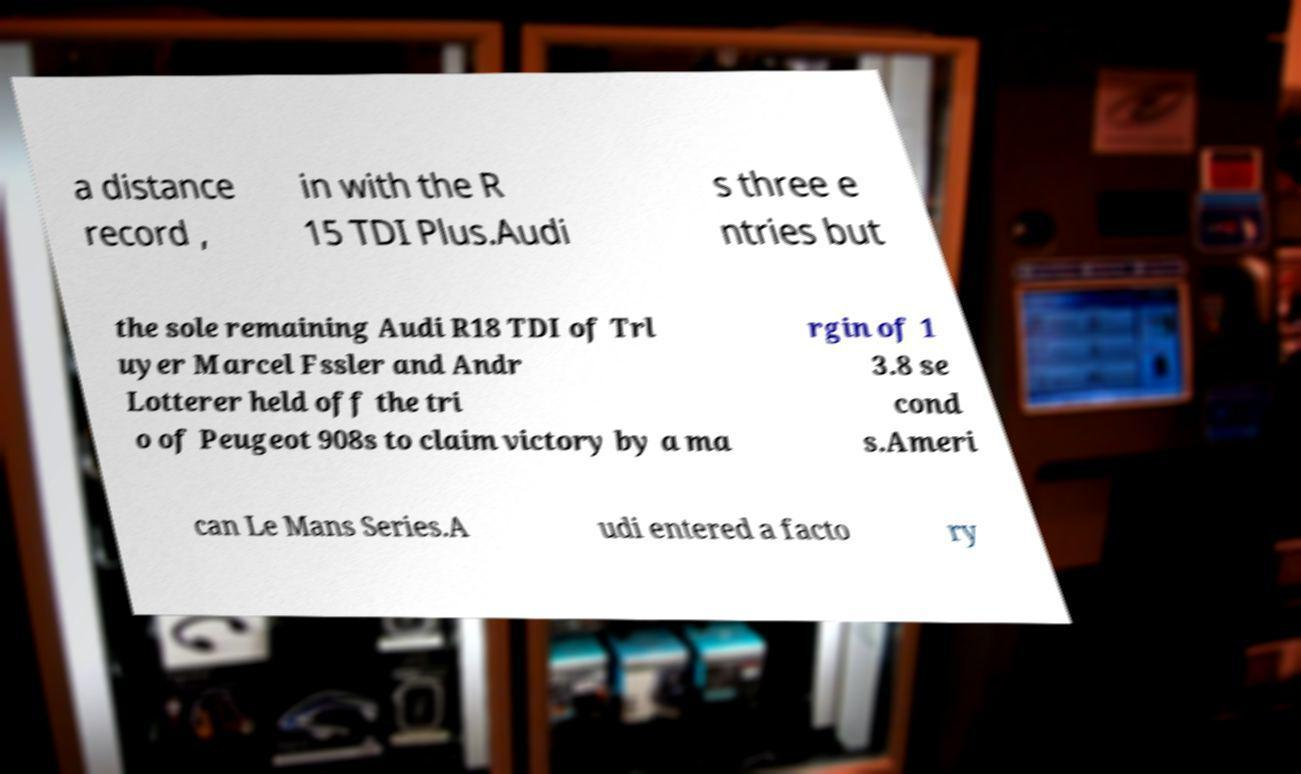Could you extract and type out the text from this image? a distance record , in with the R 15 TDI Plus.Audi s three e ntries but the sole remaining Audi R18 TDI of Trl uyer Marcel Fssler and Andr Lotterer held off the tri o of Peugeot 908s to claim victory by a ma rgin of 1 3.8 se cond s.Ameri can Le Mans Series.A udi entered a facto ry 